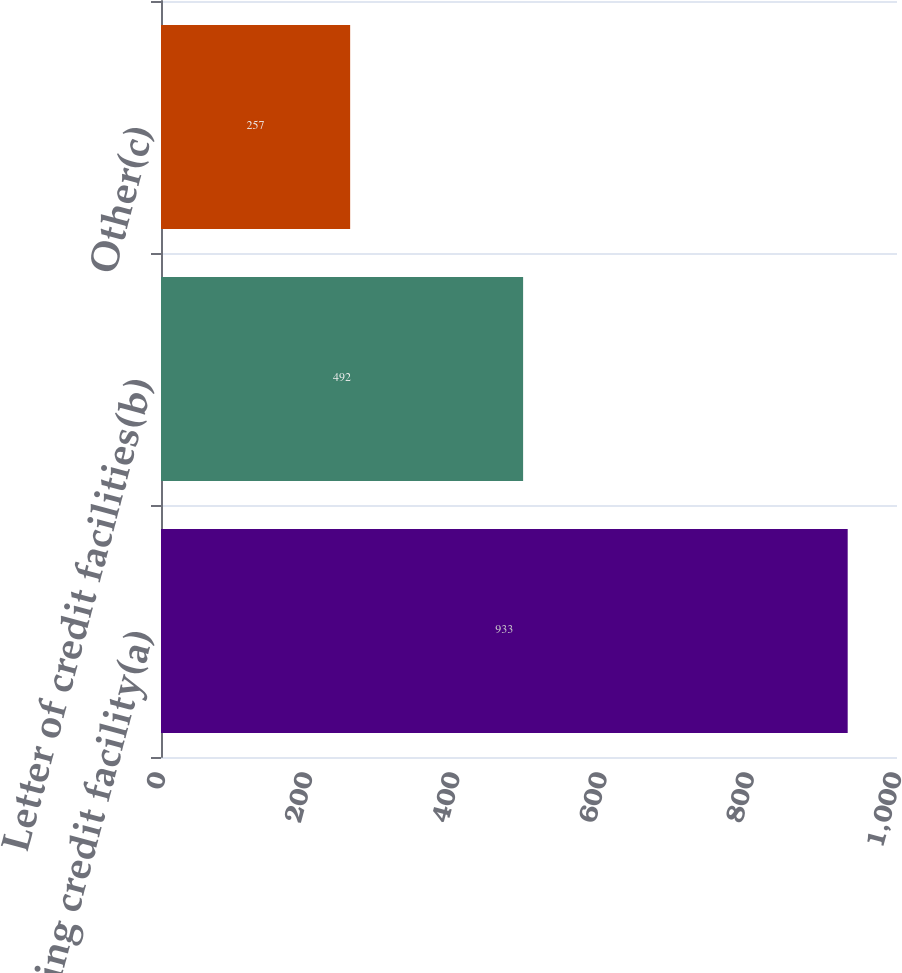<chart> <loc_0><loc_0><loc_500><loc_500><bar_chart><fcel>Revolving credit facility(a)<fcel>Letter of credit facilities(b)<fcel>Other(c)<nl><fcel>933<fcel>492<fcel>257<nl></chart> 